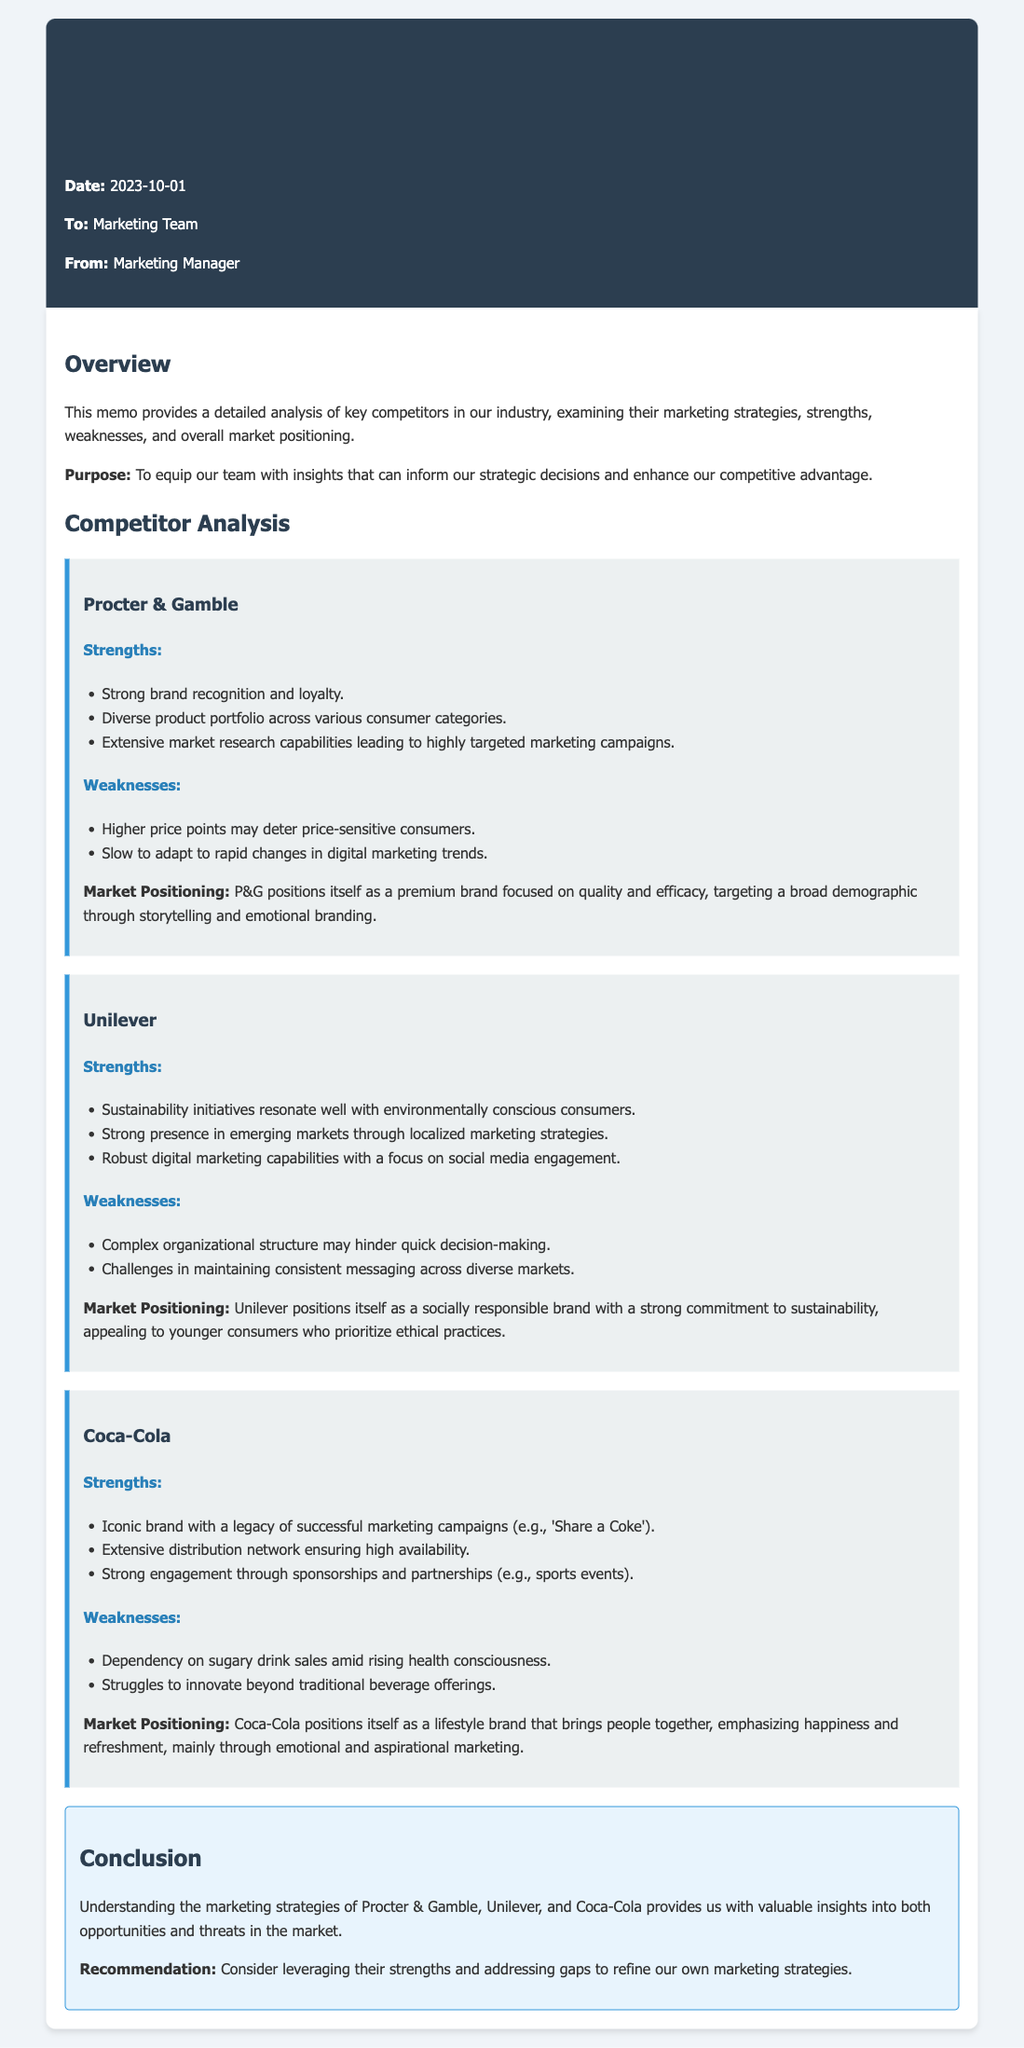What is the date of the memo? The date is mentioned at the top of the memo.
Answer: 2023-10-01 Who is the memo addressed to? The recipient is specified in the memo header.
Answer: Marketing Team What is a strength of Procter & Gamble? The document lists several strengths for P&G, one of which is highlighted.
Answer: Strong brand recognition and loyalty What is a weakness of Unilever? The weaknesses section for Unilever provides details on its shortcomings.
Answer: Complex organizational structure may hinder quick decision-making What is Coca-Cola's market positioning? The document summarizes Coca-Cola's strategic focus in a concise statement.
Answer: As a lifestyle brand that brings people together What is a recommendation mentioned in the conclusion? The conclusion includes a specific recommendation regarding marketing strategy.
Answer: Leverage their strengths and address gaps How many competitors are analyzed in the memo? The memo lists three key competitors that are analyzed in detail.
Answer: Three What type of marketing capabilities does Unilever have? The strengths section for Unilever discusses its marketing capabilities.
Answer: Robust digital marketing capabilities What is the purpose of the memo? The purpose is stated at the beginning of the memo.
Answer: To equip our team with insights 